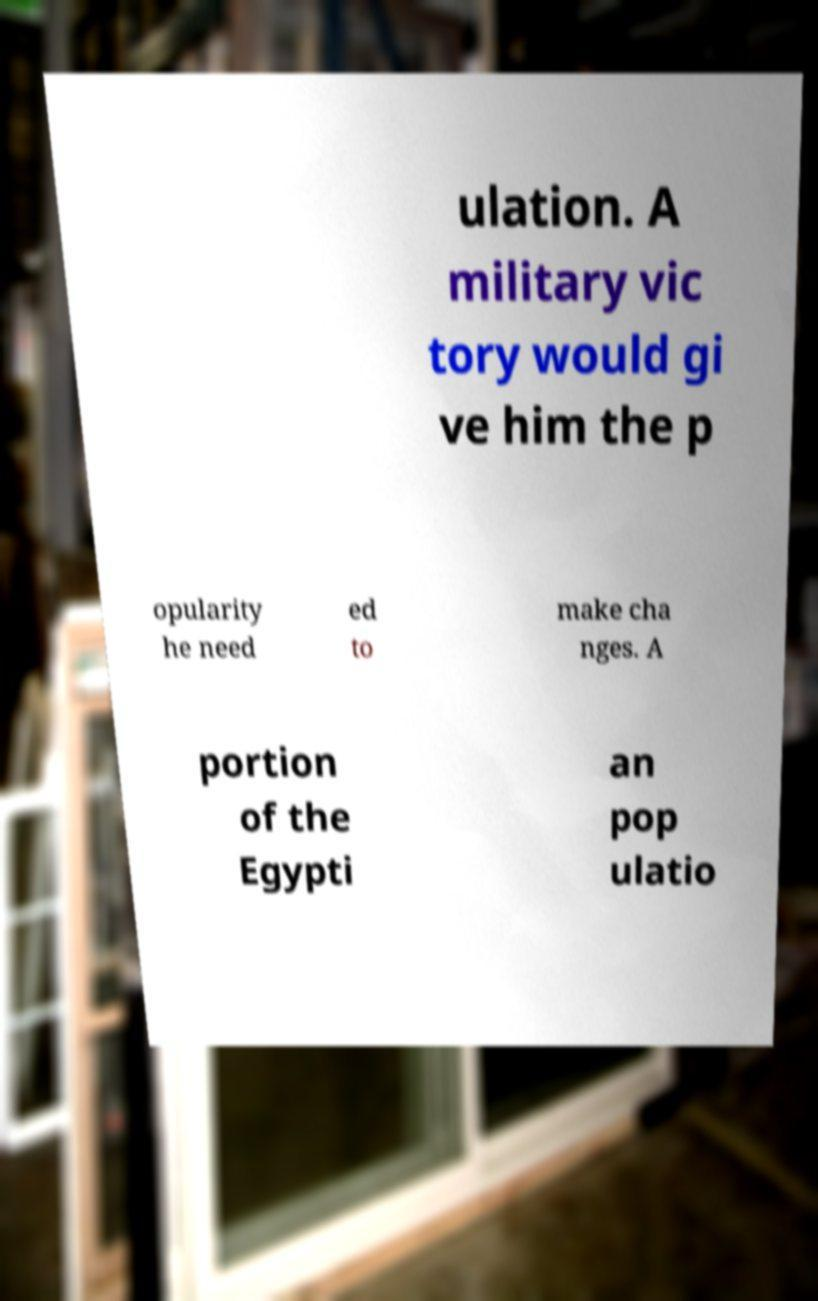I need the written content from this picture converted into text. Can you do that? ulation. A military vic tory would gi ve him the p opularity he need ed to make cha nges. A portion of the Egypti an pop ulatio 